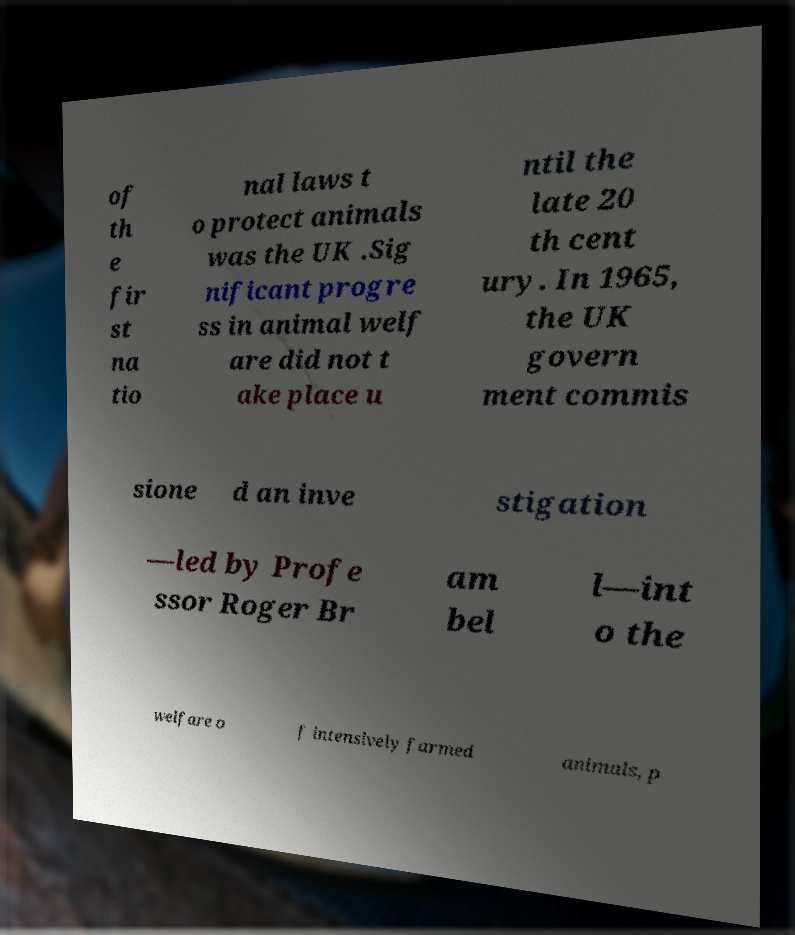For documentation purposes, I need the text within this image transcribed. Could you provide that? of th e fir st na tio nal laws t o protect animals was the UK .Sig nificant progre ss in animal welf are did not t ake place u ntil the late 20 th cent ury. In 1965, the UK govern ment commis sione d an inve stigation —led by Profe ssor Roger Br am bel l—int o the welfare o f intensively farmed animals, p 